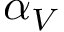Convert formula to latex. <formula><loc_0><loc_0><loc_500><loc_500>\alpha _ { V }</formula> 